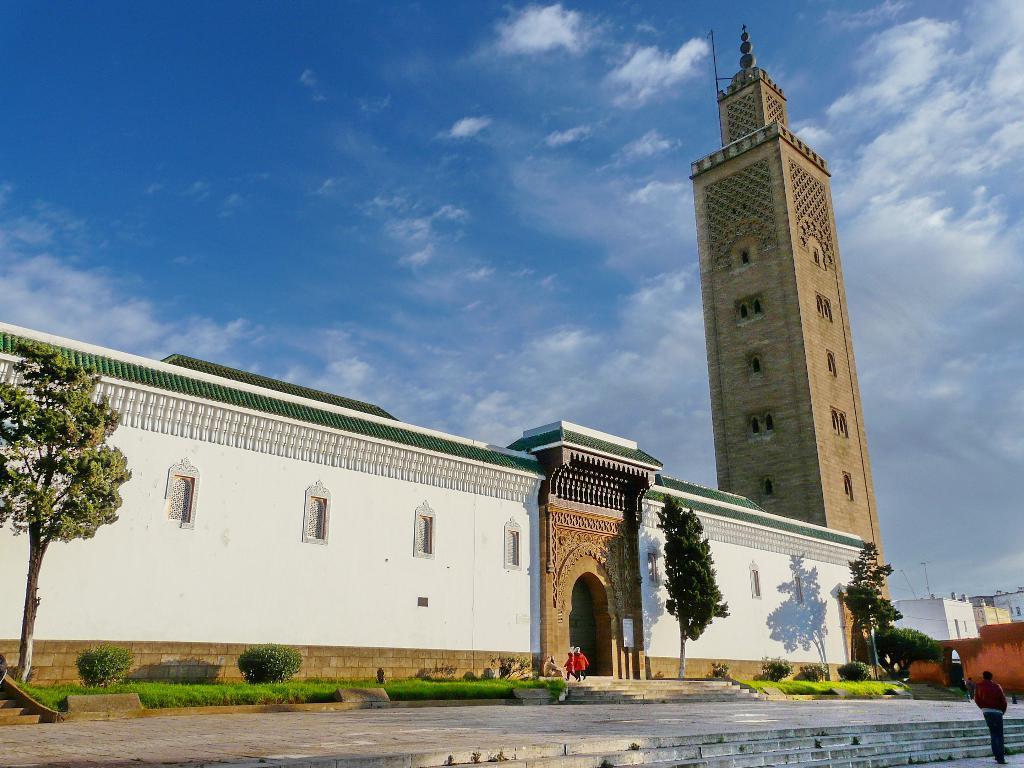What type of structure can be seen in the image? There are stairs in the image. Are there any people present in the image? Yes, there are persons standing in the image. What type of natural environment is visible in the image? There is grass and green trees visible in the image. What type of man-made structures can be seen in the image? There are buildings in the image. What is visible in the background of the image? The sky is visible in the background of the image. How many chairs are placed on the grass in the image? There are no chairs present in the image. Is it raining in the image? There is no indication of rain in the image. What type of paper is being used by the persons in the image? There is no paper visible in the image. 